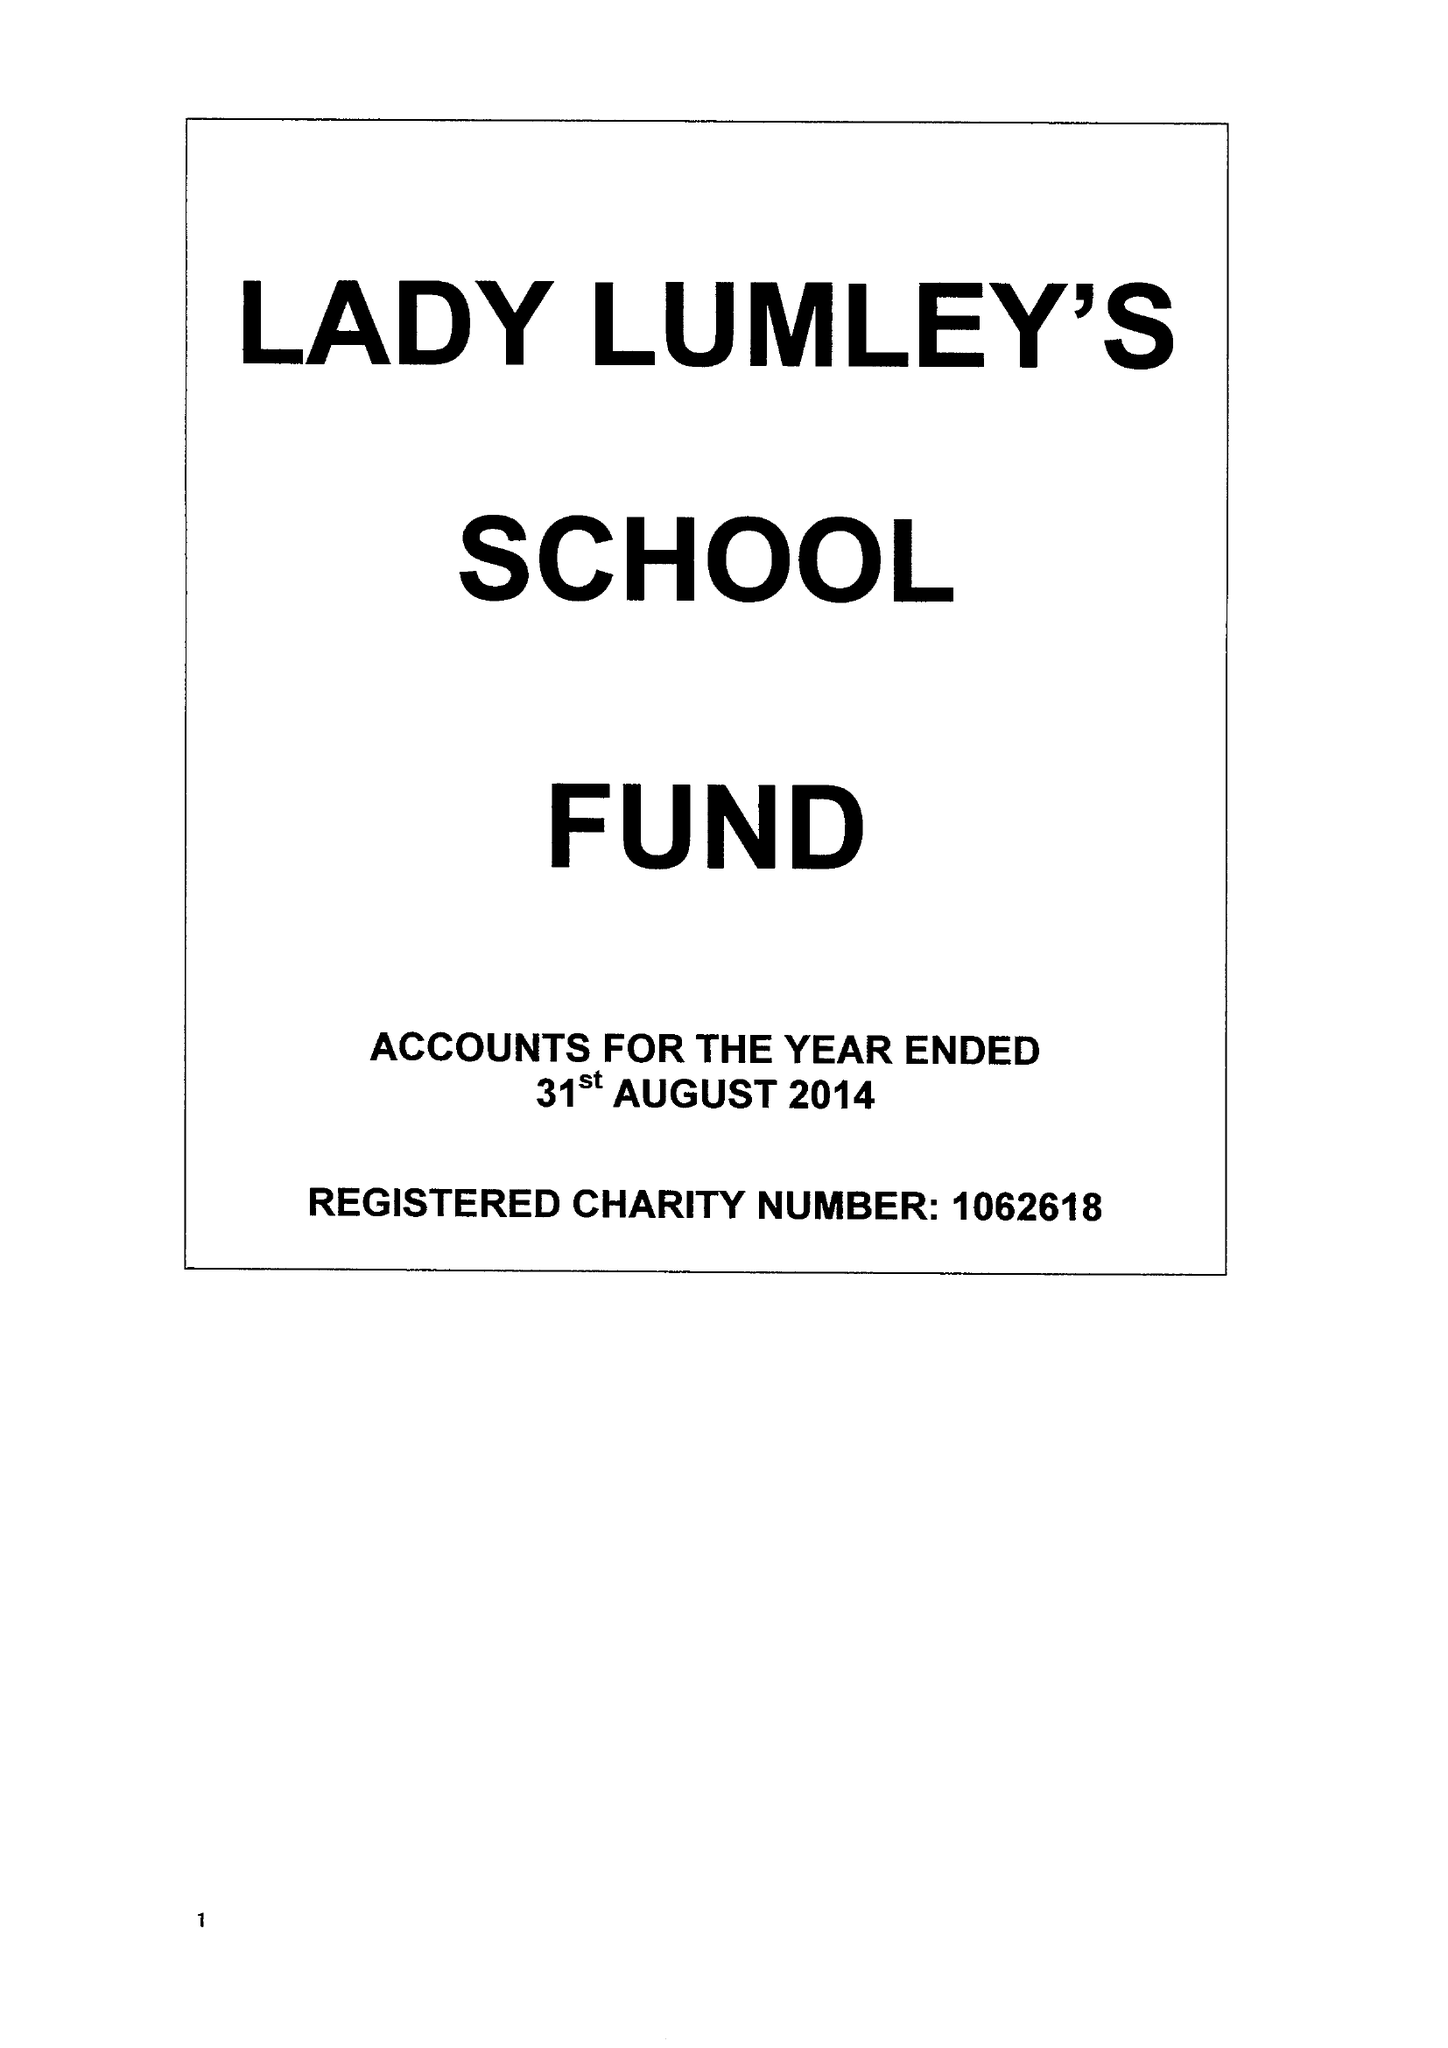What is the value for the address__post_town?
Answer the question using a single word or phrase. PICKERING 